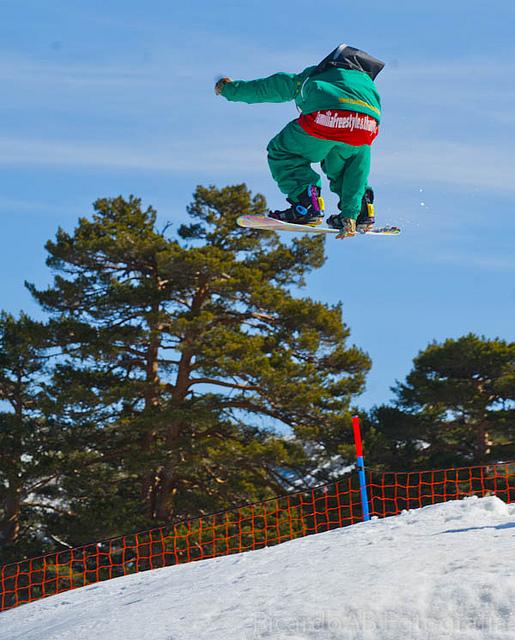Is there a fence?
Concise answer only. Yes. Is he doing a trick?
Be succinct. Yes. What color is the snowsuit?
Short answer required. Green. 